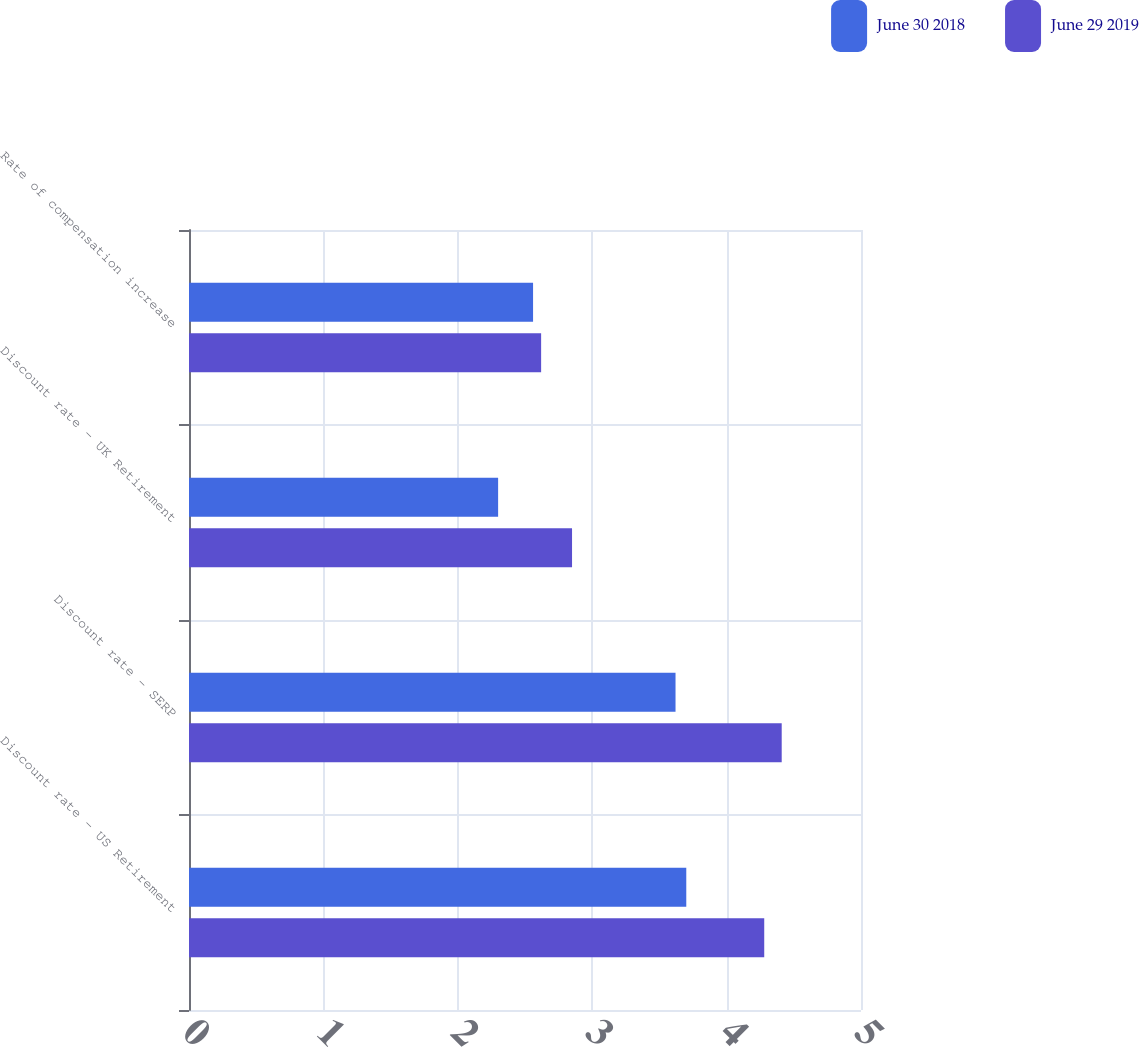<chart> <loc_0><loc_0><loc_500><loc_500><stacked_bar_chart><ecel><fcel>Discount rate - US Retirement<fcel>Discount rate - SERP<fcel>Discount rate - UK Retirement<fcel>Rate of compensation increase<nl><fcel>June 30 2018<fcel>3.7<fcel>3.62<fcel>2.3<fcel>2.56<nl><fcel>June 29 2019<fcel>4.28<fcel>4.41<fcel>2.85<fcel>2.62<nl></chart> 